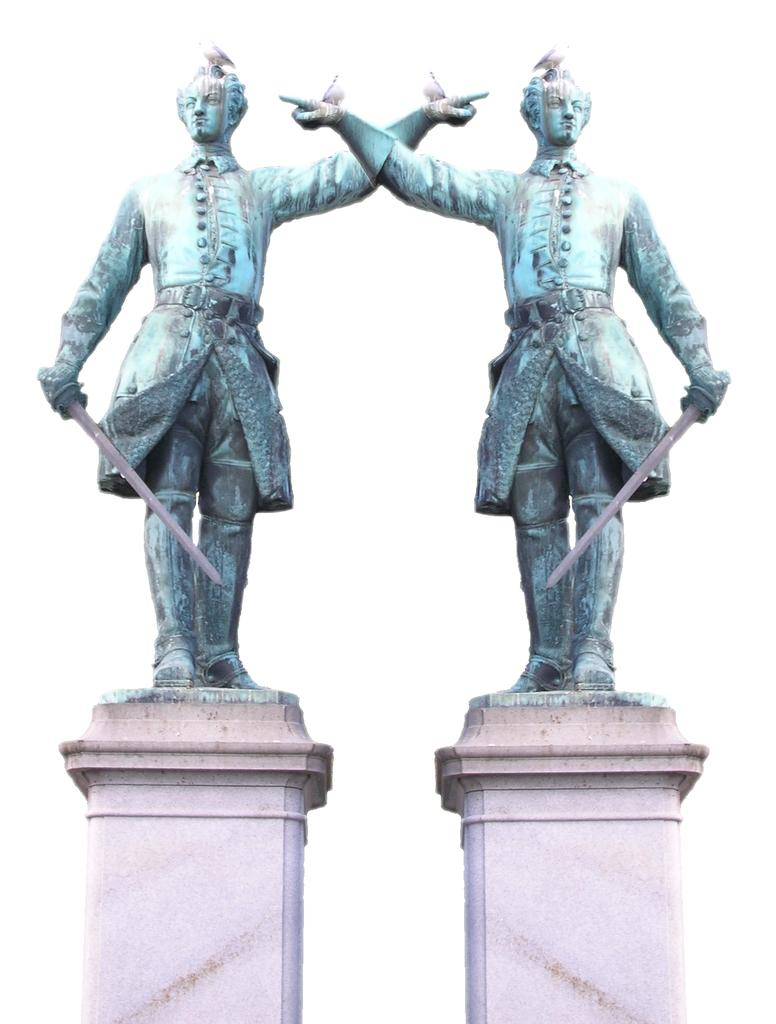How many statues are present in the image? There are two statues in the image. What is placed on the concrete stands in the image? Birds are placed on the concrete stands in the image. What type of toy can be seen being offered to the statues in the image? There is no toy present in the image, nor is there any indication that an offering is being made to the statues. 